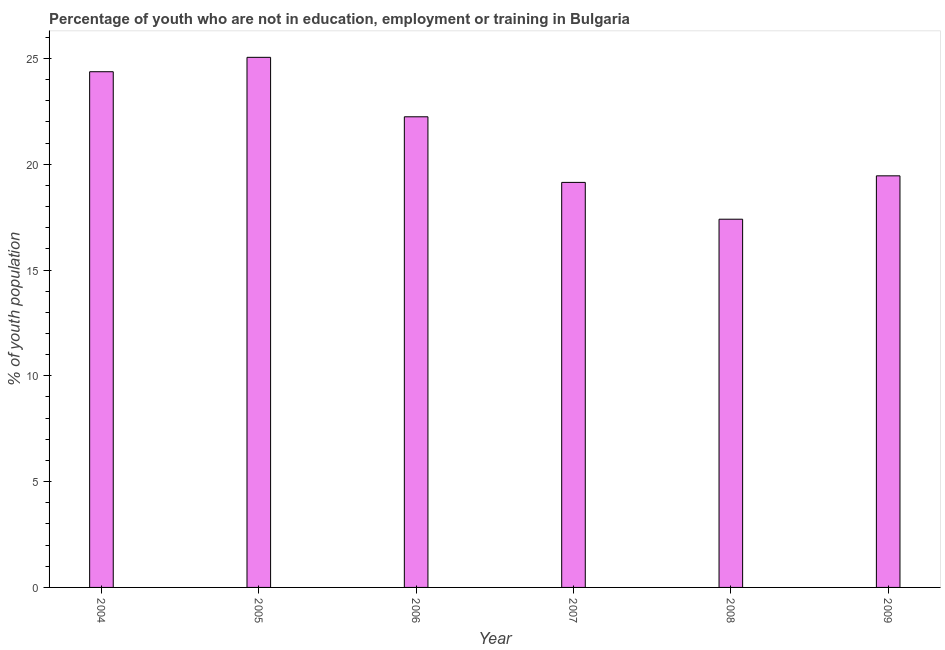What is the title of the graph?
Keep it short and to the point. Percentage of youth who are not in education, employment or training in Bulgaria. What is the label or title of the Y-axis?
Your answer should be compact. % of youth population. What is the unemployed youth population in 2009?
Make the answer very short. 19.45. Across all years, what is the maximum unemployed youth population?
Ensure brevity in your answer.  25.05. Across all years, what is the minimum unemployed youth population?
Provide a short and direct response. 17.4. In which year was the unemployed youth population maximum?
Make the answer very short. 2005. What is the sum of the unemployed youth population?
Your response must be concise. 127.65. What is the difference between the unemployed youth population in 2006 and 2008?
Your answer should be very brief. 4.84. What is the average unemployed youth population per year?
Your answer should be compact. 21.27. What is the median unemployed youth population?
Your response must be concise. 20.85. In how many years, is the unemployed youth population greater than 23 %?
Your answer should be very brief. 2. Do a majority of the years between 2008 and 2007 (inclusive) have unemployed youth population greater than 1 %?
Keep it short and to the point. No. What is the ratio of the unemployed youth population in 2006 to that in 2007?
Keep it short and to the point. 1.16. Is the difference between the unemployed youth population in 2007 and 2008 greater than the difference between any two years?
Offer a terse response. No. What is the difference between the highest and the second highest unemployed youth population?
Your answer should be compact. 0.68. Is the sum of the unemployed youth population in 2005 and 2006 greater than the maximum unemployed youth population across all years?
Offer a very short reply. Yes. What is the difference between the highest and the lowest unemployed youth population?
Your answer should be compact. 7.65. How many bars are there?
Your answer should be compact. 6. Are all the bars in the graph horizontal?
Provide a succinct answer. No. What is the % of youth population in 2004?
Keep it short and to the point. 24.37. What is the % of youth population of 2005?
Offer a very short reply. 25.05. What is the % of youth population in 2006?
Keep it short and to the point. 22.24. What is the % of youth population in 2007?
Keep it short and to the point. 19.14. What is the % of youth population in 2008?
Provide a short and direct response. 17.4. What is the % of youth population in 2009?
Offer a terse response. 19.45. What is the difference between the % of youth population in 2004 and 2005?
Your response must be concise. -0.68. What is the difference between the % of youth population in 2004 and 2006?
Offer a very short reply. 2.13. What is the difference between the % of youth population in 2004 and 2007?
Provide a short and direct response. 5.23. What is the difference between the % of youth population in 2004 and 2008?
Offer a terse response. 6.97. What is the difference between the % of youth population in 2004 and 2009?
Offer a very short reply. 4.92. What is the difference between the % of youth population in 2005 and 2006?
Provide a succinct answer. 2.81. What is the difference between the % of youth population in 2005 and 2007?
Keep it short and to the point. 5.91. What is the difference between the % of youth population in 2005 and 2008?
Give a very brief answer. 7.65. What is the difference between the % of youth population in 2005 and 2009?
Ensure brevity in your answer.  5.6. What is the difference between the % of youth population in 2006 and 2008?
Make the answer very short. 4.84. What is the difference between the % of youth population in 2006 and 2009?
Your answer should be very brief. 2.79. What is the difference between the % of youth population in 2007 and 2008?
Make the answer very short. 1.74. What is the difference between the % of youth population in 2007 and 2009?
Your answer should be compact. -0.31. What is the difference between the % of youth population in 2008 and 2009?
Make the answer very short. -2.05. What is the ratio of the % of youth population in 2004 to that in 2005?
Provide a short and direct response. 0.97. What is the ratio of the % of youth population in 2004 to that in 2006?
Your answer should be very brief. 1.1. What is the ratio of the % of youth population in 2004 to that in 2007?
Offer a terse response. 1.27. What is the ratio of the % of youth population in 2004 to that in 2008?
Make the answer very short. 1.4. What is the ratio of the % of youth population in 2004 to that in 2009?
Your answer should be compact. 1.25. What is the ratio of the % of youth population in 2005 to that in 2006?
Your answer should be very brief. 1.13. What is the ratio of the % of youth population in 2005 to that in 2007?
Ensure brevity in your answer.  1.31. What is the ratio of the % of youth population in 2005 to that in 2008?
Offer a terse response. 1.44. What is the ratio of the % of youth population in 2005 to that in 2009?
Make the answer very short. 1.29. What is the ratio of the % of youth population in 2006 to that in 2007?
Ensure brevity in your answer.  1.16. What is the ratio of the % of youth population in 2006 to that in 2008?
Provide a succinct answer. 1.28. What is the ratio of the % of youth population in 2006 to that in 2009?
Provide a succinct answer. 1.14. What is the ratio of the % of youth population in 2007 to that in 2009?
Provide a succinct answer. 0.98. What is the ratio of the % of youth population in 2008 to that in 2009?
Give a very brief answer. 0.9. 